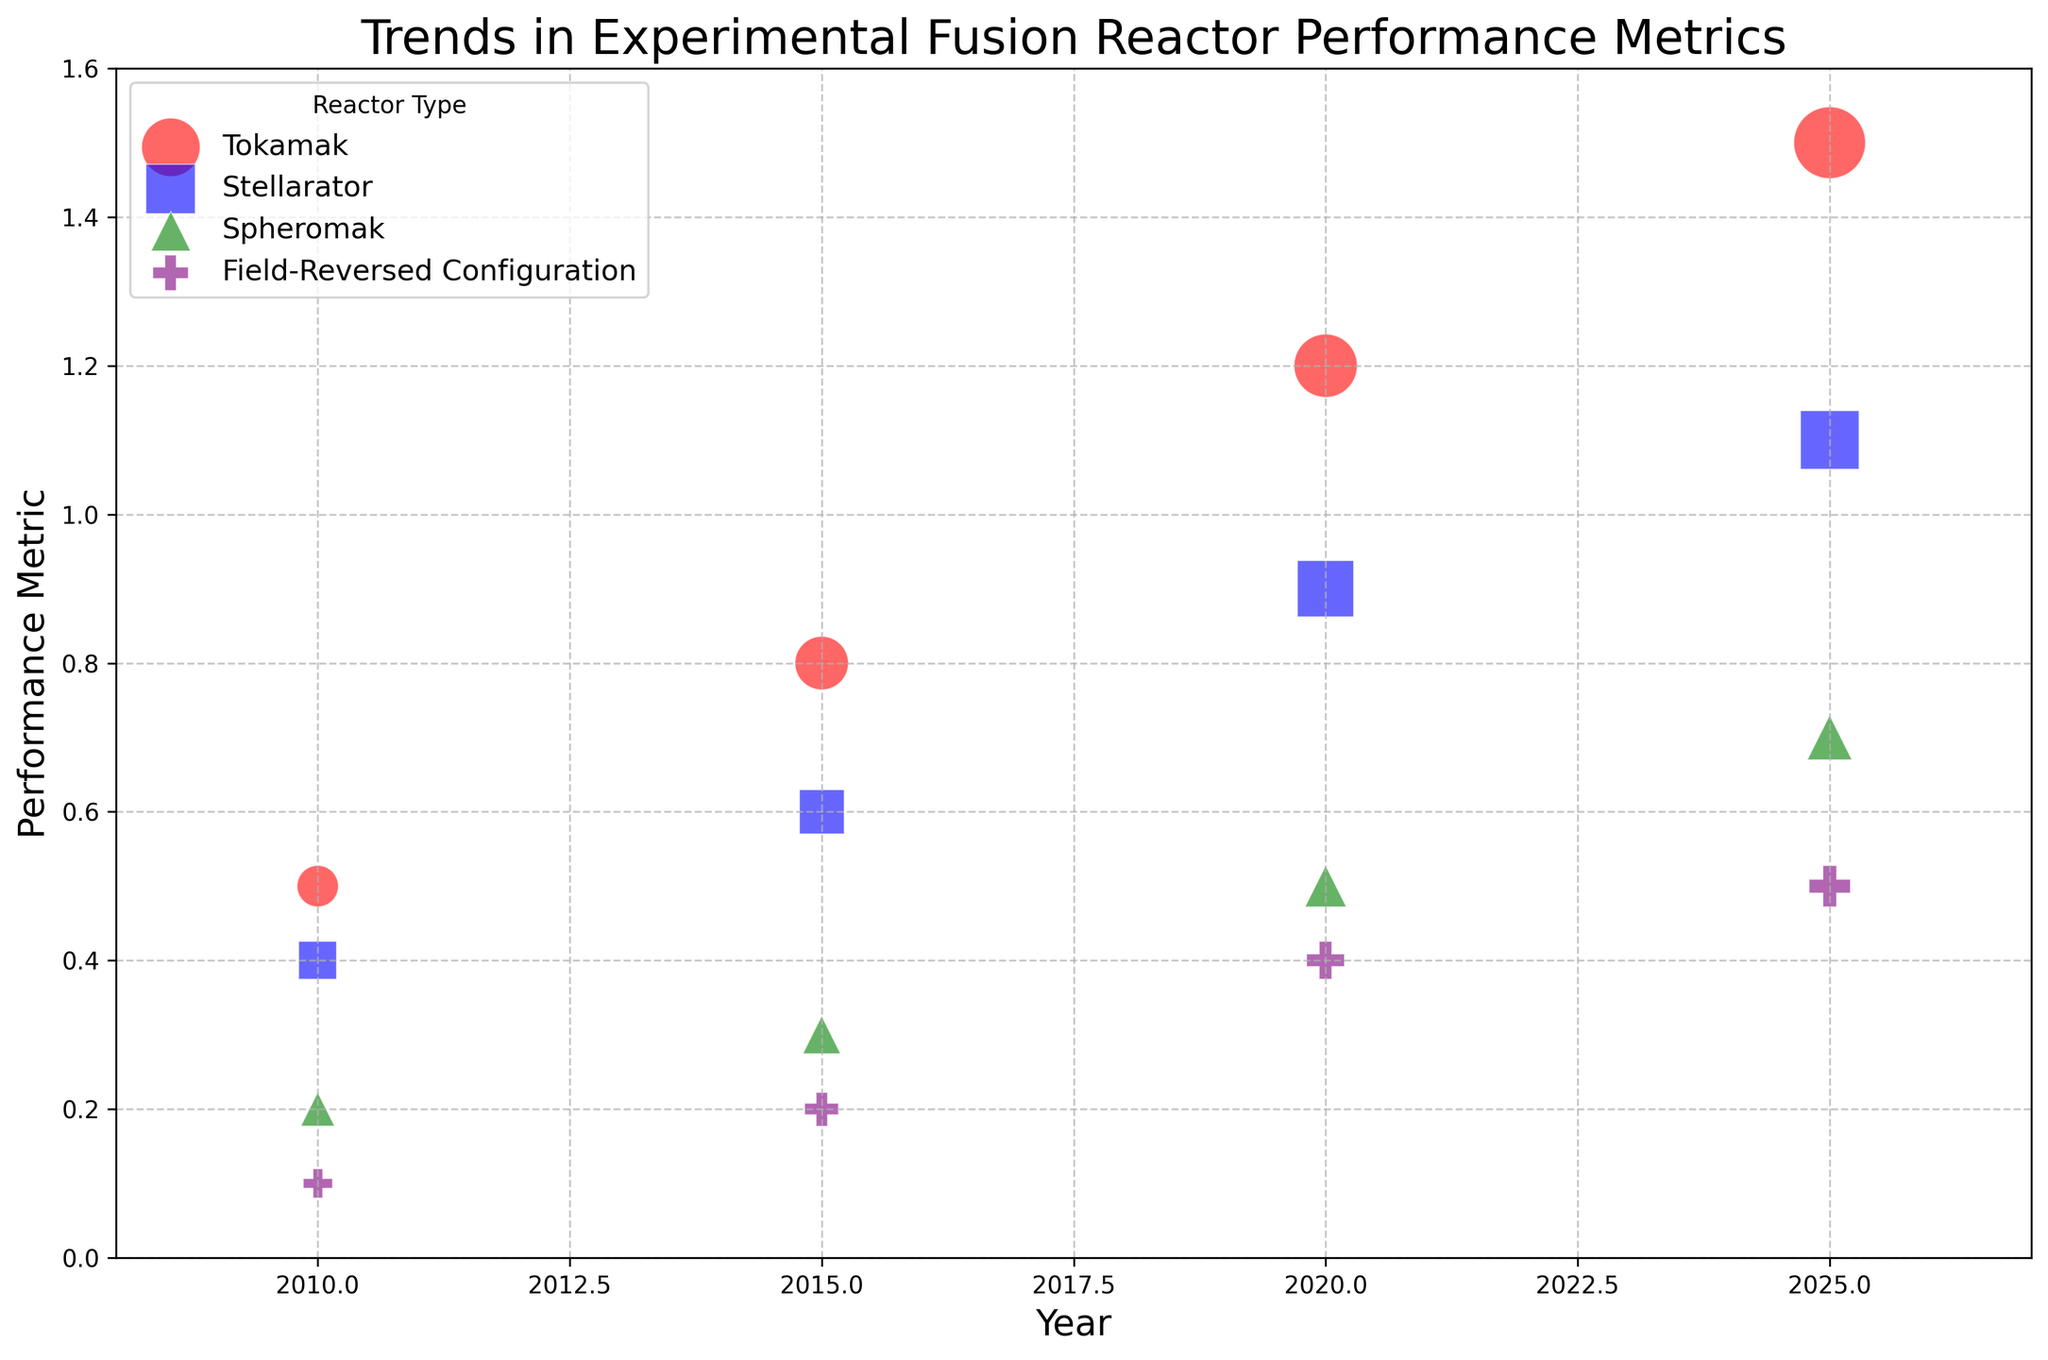Which reactor type has the highest performance metric in 2025? Look at the bubble chart and identify the performance metrics of each reactor type in 2025. Tokamak has the highest performance metric, which is 1.5.
Answer: Tokamak How does the size of the Tokamak bubble change from 2010 to 2025? Observe the sizes of the bubbles for Tokamak over the years from 2010 to 2025. In 2010, the size is 30, and in 2025, it increases to 90.
Answer: Increases Compare the performance metrics of Spheromak and Stellarator in 2015. Which one is higher? Look at the bubbles for Spheromak and Stellarator in 2015 and compare their performance metrics. Spheromak has 0.3 while Stellarator has 0.6.
Answer: Stellarator What is the trend in performance metrics for Field-Reversed Configuration from 2010 to 2025? Observe the performance metric values for Field-Reversed Configuration from 2010 through 2025. The metrics are 0.1 in 2010, 0.2 in 2015, 0.4 in 2020, and 0.5 in 2025. This shows a consistent increase over the years.
Answer: Increasing Calculate the average performance metric for Tokamak from 2010 to 2025. Add the performance metrics for Tokamak from 2010 (0.5), 2015 (0.8), 2020 (1.2), and 2025 (1.5), then divide by the number of years. (0.5 + 0.8 + 1.2 + 1.5) / 4 = 1.0
Answer: 1.0 Identify the year in which Stellarator achieves a performance metric of 0.9. Look at the bubble chart and find the year when Stellarator's performance metric reaches 0.9. This is in the year 2020.
Answer: 2020 Compare the sizes of bubbles between Tokamak and Field-Reversed Configuration in 2010 and state the difference. Identify the bubble sizes for Tokamak (30) and Field-Reversed Configuration (15) in 2010, then subtract the smaller size from the larger one. 30 - 15 = 15
Answer: 15 What is the overall trend in performance metrics for all reactor types from 2010 to 2025? Observe the performance metrics for all reactor types from 2010 to 2025. All reactor types show an increasing trend over the years.
Answer: Increasing Which two reactor types have the closest performance metrics in 2025? Compare the performance metrics of all reactor types in 2025 and find the ones with the closest values. Field-Reversed Configuration (0.5) and Spheromak (0.7) are the closest.
Answer: Field-Reversed Configuration and Spheromak 